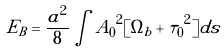<formula> <loc_0><loc_0><loc_500><loc_500>E _ { B } = \frac { a ^ { 2 } } { 8 } \int { { A _ { 0 } } ^ { 2 } [ { { \Omega } _ { b } + { \tau } _ { 0 } } ^ { 2 } ] d s }</formula> 